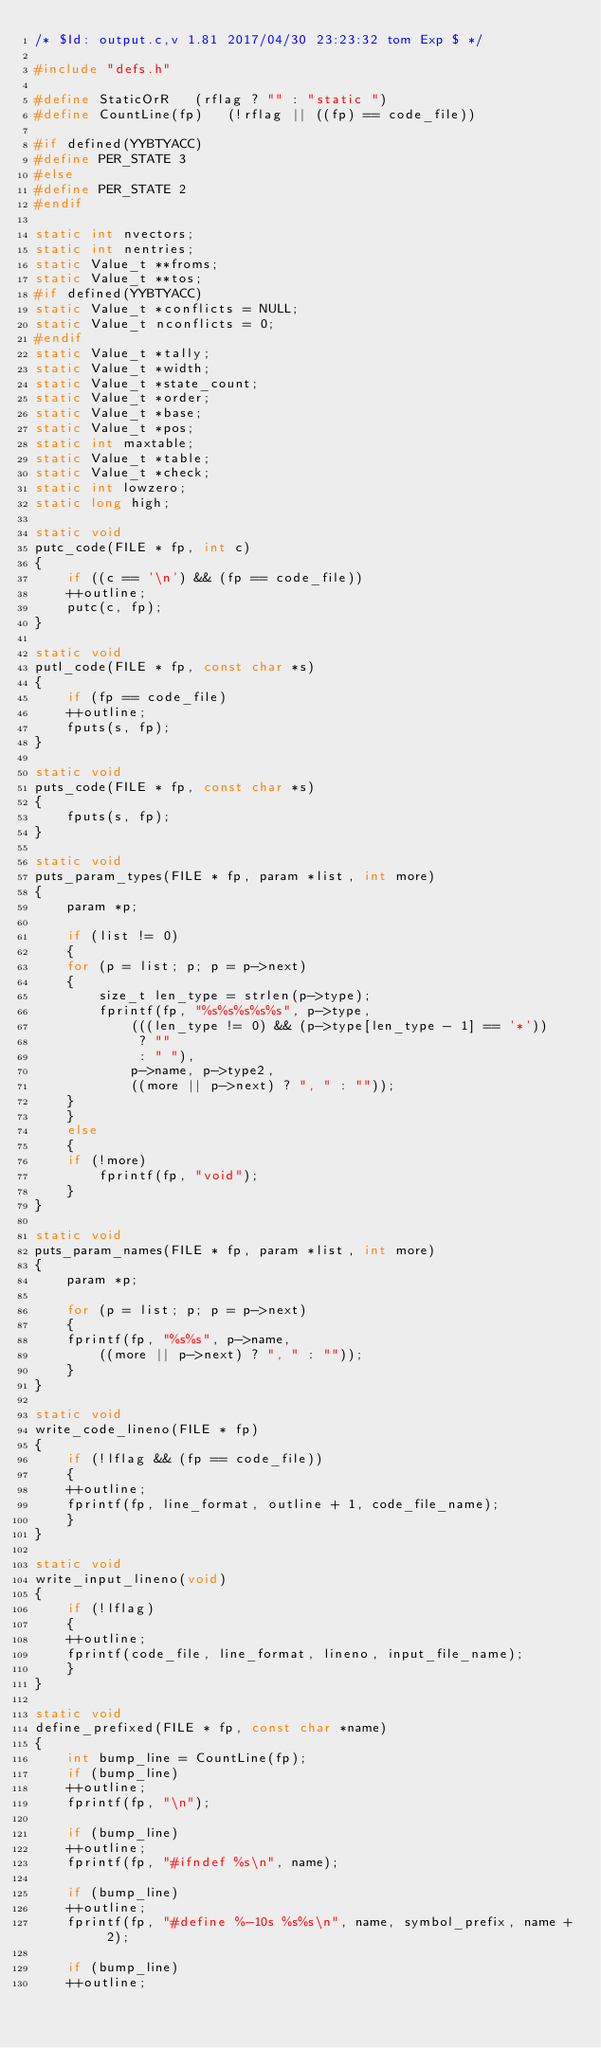Convert code to text. <code><loc_0><loc_0><loc_500><loc_500><_C_>/* $Id: output.c,v 1.81 2017/04/30 23:23:32 tom Exp $ */

#include "defs.h"

#define StaticOrR	(rflag ? "" : "static ")
#define CountLine(fp)   (!rflag || ((fp) == code_file))

#if defined(YYBTYACC)
#define PER_STATE 3
#else
#define PER_STATE 2
#endif

static int nvectors;
static int nentries;
static Value_t **froms;
static Value_t **tos;
#if defined(YYBTYACC)
static Value_t *conflicts = NULL;
static Value_t nconflicts = 0;
#endif
static Value_t *tally;
static Value_t *width;
static Value_t *state_count;
static Value_t *order;
static Value_t *base;
static Value_t *pos;
static int maxtable;
static Value_t *table;
static Value_t *check;
static int lowzero;
static long high;

static void
putc_code(FILE * fp, int c)
{
    if ((c == '\n') && (fp == code_file))
	++outline;
    putc(c, fp);
}

static void
putl_code(FILE * fp, const char *s)
{
    if (fp == code_file)
	++outline;
    fputs(s, fp);
}

static void
puts_code(FILE * fp, const char *s)
{
    fputs(s, fp);
}

static void
puts_param_types(FILE * fp, param *list, int more)
{
    param *p;

    if (list != 0)
    {
	for (p = list; p; p = p->next)
	{
	    size_t len_type = strlen(p->type);
	    fprintf(fp, "%s%s%s%s%s", p->type,
		    (((len_type != 0) && (p->type[len_type - 1] == '*'))
		     ? ""
		     : " "),
		    p->name, p->type2,
		    ((more || p->next) ? ", " : ""));
	}
    }
    else
    {
	if (!more)
	    fprintf(fp, "void");
    }
}

static void
puts_param_names(FILE * fp, param *list, int more)
{
    param *p;

    for (p = list; p; p = p->next)
    {
	fprintf(fp, "%s%s", p->name,
		((more || p->next) ? ", " : ""));
    }
}

static void
write_code_lineno(FILE * fp)
{
    if (!lflag && (fp == code_file))
    {
	++outline;
	fprintf(fp, line_format, outline + 1, code_file_name);
    }
}

static void
write_input_lineno(void)
{
    if (!lflag)
    {
	++outline;
	fprintf(code_file, line_format, lineno, input_file_name);
    }
}

static void
define_prefixed(FILE * fp, const char *name)
{
    int bump_line = CountLine(fp);
    if (bump_line)
	++outline;
    fprintf(fp, "\n");

    if (bump_line)
	++outline;
    fprintf(fp, "#ifndef %s\n", name);

    if (bump_line)
	++outline;
    fprintf(fp, "#define %-10s %s%s\n", name, symbol_prefix, name + 2);

    if (bump_line)
	++outline;</code> 